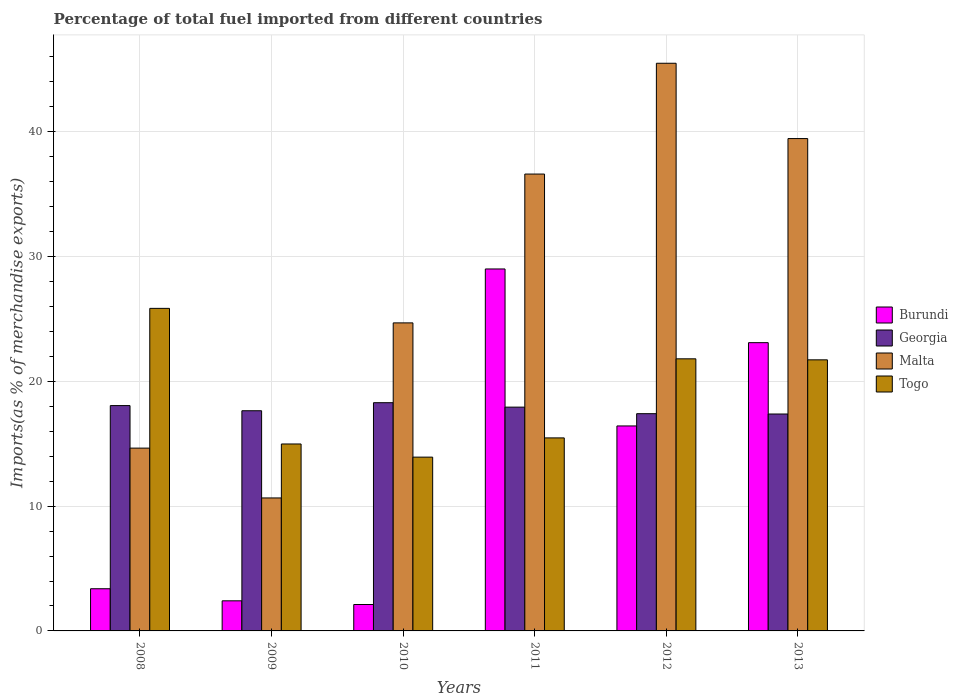How many groups of bars are there?
Provide a succinct answer. 6. Are the number of bars on each tick of the X-axis equal?
Give a very brief answer. Yes. How many bars are there on the 5th tick from the left?
Provide a succinct answer. 4. How many bars are there on the 6th tick from the right?
Your answer should be compact. 4. In how many cases, is the number of bars for a given year not equal to the number of legend labels?
Ensure brevity in your answer.  0. What is the percentage of imports to different countries in Togo in 2011?
Offer a very short reply. 15.47. Across all years, what is the maximum percentage of imports to different countries in Burundi?
Keep it short and to the point. 29. Across all years, what is the minimum percentage of imports to different countries in Georgia?
Offer a terse response. 17.38. In which year was the percentage of imports to different countries in Togo maximum?
Make the answer very short. 2008. What is the total percentage of imports to different countries in Burundi in the graph?
Offer a very short reply. 76.43. What is the difference between the percentage of imports to different countries in Burundi in 2011 and that in 2012?
Provide a succinct answer. 12.58. What is the difference between the percentage of imports to different countries in Togo in 2008 and the percentage of imports to different countries in Malta in 2011?
Your answer should be very brief. -10.76. What is the average percentage of imports to different countries in Togo per year?
Offer a terse response. 18.96. In the year 2008, what is the difference between the percentage of imports to different countries in Malta and percentage of imports to different countries in Burundi?
Your answer should be compact. 11.27. What is the ratio of the percentage of imports to different countries in Togo in 2009 to that in 2012?
Provide a succinct answer. 0.69. Is the percentage of imports to different countries in Malta in 2010 less than that in 2011?
Your response must be concise. Yes. What is the difference between the highest and the second highest percentage of imports to different countries in Georgia?
Offer a very short reply. 0.23. What is the difference between the highest and the lowest percentage of imports to different countries in Burundi?
Give a very brief answer. 26.89. In how many years, is the percentage of imports to different countries in Burundi greater than the average percentage of imports to different countries in Burundi taken over all years?
Your response must be concise. 3. Is the sum of the percentage of imports to different countries in Georgia in 2011 and 2012 greater than the maximum percentage of imports to different countries in Burundi across all years?
Provide a short and direct response. Yes. What does the 2nd bar from the left in 2013 represents?
Offer a terse response. Georgia. What does the 1st bar from the right in 2012 represents?
Ensure brevity in your answer.  Togo. Is it the case that in every year, the sum of the percentage of imports to different countries in Malta and percentage of imports to different countries in Togo is greater than the percentage of imports to different countries in Georgia?
Keep it short and to the point. Yes. How many years are there in the graph?
Offer a very short reply. 6. Does the graph contain grids?
Offer a terse response. Yes. Where does the legend appear in the graph?
Your answer should be compact. Center right. How are the legend labels stacked?
Ensure brevity in your answer.  Vertical. What is the title of the graph?
Provide a short and direct response. Percentage of total fuel imported from different countries. Does "Arab World" appear as one of the legend labels in the graph?
Give a very brief answer. No. What is the label or title of the Y-axis?
Ensure brevity in your answer.  Imports(as % of merchandise exports). What is the Imports(as % of merchandise exports) of Burundi in 2008?
Offer a terse response. 3.38. What is the Imports(as % of merchandise exports) in Georgia in 2008?
Keep it short and to the point. 18.06. What is the Imports(as % of merchandise exports) in Malta in 2008?
Your answer should be compact. 14.65. What is the Imports(as % of merchandise exports) in Togo in 2008?
Your answer should be very brief. 25.85. What is the Imports(as % of merchandise exports) of Burundi in 2009?
Provide a short and direct response. 2.41. What is the Imports(as % of merchandise exports) in Georgia in 2009?
Offer a very short reply. 17.64. What is the Imports(as % of merchandise exports) in Malta in 2009?
Provide a succinct answer. 10.66. What is the Imports(as % of merchandise exports) of Togo in 2009?
Give a very brief answer. 14.98. What is the Imports(as % of merchandise exports) in Burundi in 2010?
Your answer should be compact. 2.12. What is the Imports(as % of merchandise exports) in Georgia in 2010?
Give a very brief answer. 18.29. What is the Imports(as % of merchandise exports) of Malta in 2010?
Give a very brief answer. 24.68. What is the Imports(as % of merchandise exports) of Togo in 2010?
Your answer should be very brief. 13.93. What is the Imports(as % of merchandise exports) of Burundi in 2011?
Provide a succinct answer. 29. What is the Imports(as % of merchandise exports) in Georgia in 2011?
Offer a very short reply. 17.93. What is the Imports(as % of merchandise exports) of Malta in 2011?
Provide a succinct answer. 36.61. What is the Imports(as % of merchandise exports) in Togo in 2011?
Offer a very short reply. 15.47. What is the Imports(as % of merchandise exports) in Burundi in 2012?
Your response must be concise. 16.42. What is the Imports(as % of merchandise exports) in Georgia in 2012?
Provide a short and direct response. 17.41. What is the Imports(as % of merchandise exports) of Malta in 2012?
Your response must be concise. 45.49. What is the Imports(as % of merchandise exports) in Togo in 2012?
Keep it short and to the point. 21.8. What is the Imports(as % of merchandise exports) of Burundi in 2013?
Your response must be concise. 23.1. What is the Imports(as % of merchandise exports) in Georgia in 2013?
Keep it short and to the point. 17.38. What is the Imports(as % of merchandise exports) in Malta in 2013?
Keep it short and to the point. 39.45. What is the Imports(as % of merchandise exports) in Togo in 2013?
Your response must be concise. 21.72. Across all years, what is the maximum Imports(as % of merchandise exports) in Burundi?
Keep it short and to the point. 29. Across all years, what is the maximum Imports(as % of merchandise exports) of Georgia?
Provide a short and direct response. 18.29. Across all years, what is the maximum Imports(as % of merchandise exports) of Malta?
Ensure brevity in your answer.  45.49. Across all years, what is the maximum Imports(as % of merchandise exports) in Togo?
Offer a very short reply. 25.85. Across all years, what is the minimum Imports(as % of merchandise exports) of Burundi?
Keep it short and to the point. 2.12. Across all years, what is the minimum Imports(as % of merchandise exports) in Georgia?
Keep it short and to the point. 17.38. Across all years, what is the minimum Imports(as % of merchandise exports) of Malta?
Offer a very short reply. 10.66. Across all years, what is the minimum Imports(as % of merchandise exports) of Togo?
Offer a very short reply. 13.93. What is the total Imports(as % of merchandise exports) of Burundi in the graph?
Keep it short and to the point. 76.43. What is the total Imports(as % of merchandise exports) in Georgia in the graph?
Keep it short and to the point. 106.7. What is the total Imports(as % of merchandise exports) of Malta in the graph?
Offer a very short reply. 171.53. What is the total Imports(as % of merchandise exports) in Togo in the graph?
Keep it short and to the point. 113.74. What is the difference between the Imports(as % of merchandise exports) in Burundi in 2008 and that in 2009?
Your response must be concise. 0.97. What is the difference between the Imports(as % of merchandise exports) of Georgia in 2008 and that in 2009?
Offer a terse response. 0.41. What is the difference between the Imports(as % of merchandise exports) of Malta in 2008 and that in 2009?
Give a very brief answer. 3.99. What is the difference between the Imports(as % of merchandise exports) of Togo in 2008 and that in 2009?
Provide a succinct answer. 10.87. What is the difference between the Imports(as % of merchandise exports) of Burundi in 2008 and that in 2010?
Your answer should be very brief. 1.26. What is the difference between the Imports(as % of merchandise exports) of Georgia in 2008 and that in 2010?
Give a very brief answer. -0.23. What is the difference between the Imports(as % of merchandise exports) of Malta in 2008 and that in 2010?
Provide a succinct answer. -10.03. What is the difference between the Imports(as % of merchandise exports) in Togo in 2008 and that in 2010?
Make the answer very short. 11.92. What is the difference between the Imports(as % of merchandise exports) of Burundi in 2008 and that in 2011?
Your answer should be compact. -25.62. What is the difference between the Imports(as % of merchandise exports) in Georgia in 2008 and that in 2011?
Offer a terse response. 0.12. What is the difference between the Imports(as % of merchandise exports) of Malta in 2008 and that in 2011?
Ensure brevity in your answer.  -21.96. What is the difference between the Imports(as % of merchandise exports) of Togo in 2008 and that in 2011?
Your answer should be very brief. 10.38. What is the difference between the Imports(as % of merchandise exports) in Burundi in 2008 and that in 2012?
Make the answer very short. -13.04. What is the difference between the Imports(as % of merchandise exports) in Georgia in 2008 and that in 2012?
Your answer should be very brief. 0.65. What is the difference between the Imports(as % of merchandise exports) in Malta in 2008 and that in 2012?
Make the answer very short. -30.84. What is the difference between the Imports(as % of merchandise exports) of Togo in 2008 and that in 2012?
Give a very brief answer. 4.04. What is the difference between the Imports(as % of merchandise exports) in Burundi in 2008 and that in 2013?
Offer a terse response. -19.72. What is the difference between the Imports(as % of merchandise exports) in Georgia in 2008 and that in 2013?
Offer a terse response. 0.67. What is the difference between the Imports(as % of merchandise exports) in Malta in 2008 and that in 2013?
Offer a very short reply. -24.8. What is the difference between the Imports(as % of merchandise exports) in Togo in 2008 and that in 2013?
Your answer should be compact. 4.12. What is the difference between the Imports(as % of merchandise exports) of Burundi in 2009 and that in 2010?
Your response must be concise. 0.3. What is the difference between the Imports(as % of merchandise exports) in Georgia in 2009 and that in 2010?
Offer a very short reply. -0.65. What is the difference between the Imports(as % of merchandise exports) in Malta in 2009 and that in 2010?
Offer a terse response. -14.03. What is the difference between the Imports(as % of merchandise exports) in Togo in 2009 and that in 2010?
Give a very brief answer. 1.05. What is the difference between the Imports(as % of merchandise exports) of Burundi in 2009 and that in 2011?
Your response must be concise. -26.59. What is the difference between the Imports(as % of merchandise exports) of Georgia in 2009 and that in 2011?
Your answer should be very brief. -0.29. What is the difference between the Imports(as % of merchandise exports) of Malta in 2009 and that in 2011?
Offer a terse response. -25.95. What is the difference between the Imports(as % of merchandise exports) of Togo in 2009 and that in 2011?
Your response must be concise. -0.49. What is the difference between the Imports(as % of merchandise exports) of Burundi in 2009 and that in 2012?
Keep it short and to the point. -14.01. What is the difference between the Imports(as % of merchandise exports) of Georgia in 2009 and that in 2012?
Make the answer very short. 0.23. What is the difference between the Imports(as % of merchandise exports) of Malta in 2009 and that in 2012?
Ensure brevity in your answer.  -34.83. What is the difference between the Imports(as % of merchandise exports) of Togo in 2009 and that in 2012?
Your answer should be compact. -6.82. What is the difference between the Imports(as % of merchandise exports) of Burundi in 2009 and that in 2013?
Make the answer very short. -20.69. What is the difference between the Imports(as % of merchandise exports) in Georgia in 2009 and that in 2013?
Keep it short and to the point. 0.26. What is the difference between the Imports(as % of merchandise exports) of Malta in 2009 and that in 2013?
Keep it short and to the point. -28.8. What is the difference between the Imports(as % of merchandise exports) of Togo in 2009 and that in 2013?
Provide a succinct answer. -6.74. What is the difference between the Imports(as % of merchandise exports) of Burundi in 2010 and that in 2011?
Offer a terse response. -26.89. What is the difference between the Imports(as % of merchandise exports) in Georgia in 2010 and that in 2011?
Ensure brevity in your answer.  0.36. What is the difference between the Imports(as % of merchandise exports) of Malta in 2010 and that in 2011?
Provide a succinct answer. -11.92. What is the difference between the Imports(as % of merchandise exports) in Togo in 2010 and that in 2011?
Provide a succinct answer. -1.54. What is the difference between the Imports(as % of merchandise exports) of Burundi in 2010 and that in 2012?
Your answer should be very brief. -14.31. What is the difference between the Imports(as % of merchandise exports) in Georgia in 2010 and that in 2012?
Ensure brevity in your answer.  0.88. What is the difference between the Imports(as % of merchandise exports) in Malta in 2010 and that in 2012?
Offer a very short reply. -20.8. What is the difference between the Imports(as % of merchandise exports) in Togo in 2010 and that in 2012?
Offer a terse response. -7.88. What is the difference between the Imports(as % of merchandise exports) in Burundi in 2010 and that in 2013?
Provide a short and direct response. -20.98. What is the difference between the Imports(as % of merchandise exports) in Georgia in 2010 and that in 2013?
Your answer should be compact. 0.91. What is the difference between the Imports(as % of merchandise exports) of Malta in 2010 and that in 2013?
Offer a terse response. -14.77. What is the difference between the Imports(as % of merchandise exports) of Togo in 2010 and that in 2013?
Ensure brevity in your answer.  -7.8. What is the difference between the Imports(as % of merchandise exports) of Burundi in 2011 and that in 2012?
Your answer should be compact. 12.58. What is the difference between the Imports(as % of merchandise exports) of Georgia in 2011 and that in 2012?
Ensure brevity in your answer.  0.52. What is the difference between the Imports(as % of merchandise exports) in Malta in 2011 and that in 2012?
Offer a very short reply. -8.88. What is the difference between the Imports(as % of merchandise exports) of Togo in 2011 and that in 2012?
Ensure brevity in your answer.  -6.34. What is the difference between the Imports(as % of merchandise exports) of Burundi in 2011 and that in 2013?
Give a very brief answer. 5.91. What is the difference between the Imports(as % of merchandise exports) of Georgia in 2011 and that in 2013?
Provide a succinct answer. 0.55. What is the difference between the Imports(as % of merchandise exports) of Malta in 2011 and that in 2013?
Provide a succinct answer. -2.84. What is the difference between the Imports(as % of merchandise exports) of Togo in 2011 and that in 2013?
Your answer should be very brief. -6.25. What is the difference between the Imports(as % of merchandise exports) of Burundi in 2012 and that in 2013?
Your answer should be compact. -6.67. What is the difference between the Imports(as % of merchandise exports) of Georgia in 2012 and that in 2013?
Ensure brevity in your answer.  0.03. What is the difference between the Imports(as % of merchandise exports) of Malta in 2012 and that in 2013?
Your response must be concise. 6.03. What is the difference between the Imports(as % of merchandise exports) in Togo in 2012 and that in 2013?
Your answer should be very brief. 0.08. What is the difference between the Imports(as % of merchandise exports) of Burundi in 2008 and the Imports(as % of merchandise exports) of Georgia in 2009?
Keep it short and to the point. -14.26. What is the difference between the Imports(as % of merchandise exports) of Burundi in 2008 and the Imports(as % of merchandise exports) of Malta in 2009?
Your answer should be very brief. -7.28. What is the difference between the Imports(as % of merchandise exports) in Burundi in 2008 and the Imports(as % of merchandise exports) in Togo in 2009?
Provide a short and direct response. -11.6. What is the difference between the Imports(as % of merchandise exports) in Georgia in 2008 and the Imports(as % of merchandise exports) in Malta in 2009?
Your answer should be very brief. 7.4. What is the difference between the Imports(as % of merchandise exports) of Georgia in 2008 and the Imports(as % of merchandise exports) of Togo in 2009?
Offer a very short reply. 3.08. What is the difference between the Imports(as % of merchandise exports) of Malta in 2008 and the Imports(as % of merchandise exports) of Togo in 2009?
Ensure brevity in your answer.  -0.33. What is the difference between the Imports(as % of merchandise exports) of Burundi in 2008 and the Imports(as % of merchandise exports) of Georgia in 2010?
Offer a terse response. -14.91. What is the difference between the Imports(as % of merchandise exports) of Burundi in 2008 and the Imports(as % of merchandise exports) of Malta in 2010?
Provide a short and direct response. -21.3. What is the difference between the Imports(as % of merchandise exports) in Burundi in 2008 and the Imports(as % of merchandise exports) in Togo in 2010?
Your answer should be very brief. -10.55. What is the difference between the Imports(as % of merchandise exports) of Georgia in 2008 and the Imports(as % of merchandise exports) of Malta in 2010?
Your response must be concise. -6.63. What is the difference between the Imports(as % of merchandise exports) of Georgia in 2008 and the Imports(as % of merchandise exports) of Togo in 2010?
Give a very brief answer. 4.13. What is the difference between the Imports(as % of merchandise exports) in Malta in 2008 and the Imports(as % of merchandise exports) in Togo in 2010?
Your response must be concise. 0.72. What is the difference between the Imports(as % of merchandise exports) in Burundi in 2008 and the Imports(as % of merchandise exports) in Georgia in 2011?
Your answer should be compact. -14.55. What is the difference between the Imports(as % of merchandise exports) of Burundi in 2008 and the Imports(as % of merchandise exports) of Malta in 2011?
Offer a terse response. -33.23. What is the difference between the Imports(as % of merchandise exports) in Burundi in 2008 and the Imports(as % of merchandise exports) in Togo in 2011?
Your response must be concise. -12.09. What is the difference between the Imports(as % of merchandise exports) of Georgia in 2008 and the Imports(as % of merchandise exports) of Malta in 2011?
Your response must be concise. -18.55. What is the difference between the Imports(as % of merchandise exports) in Georgia in 2008 and the Imports(as % of merchandise exports) in Togo in 2011?
Keep it short and to the point. 2.59. What is the difference between the Imports(as % of merchandise exports) in Malta in 2008 and the Imports(as % of merchandise exports) in Togo in 2011?
Give a very brief answer. -0.82. What is the difference between the Imports(as % of merchandise exports) in Burundi in 2008 and the Imports(as % of merchandise exports) in Georgia in 2012?
Provide a short and direct response. -14.03. What is the difference between the Imports(as % of merchandise exports) in Burundi in 2008 and the Imports(as % of merchandise exports) in Malta in 2012?
Give a very brief answer. -42.11. What is the difference between the Imports(as % of merchandise exports) in Burundi in 2008 and the Imports(as % of merchandise exports) in Togo in 2012?
Provide a succinct answer. -18.42. What is the difference between the Imports(as % of merchandise exports) of Georgia in 2008 and the Imports(as % of merchandise exports) of Malta in 2012?
Give a very brief answer. -27.43. What is the difference between the Imports(as % of merchandise exports) in Georgia in 2008 and the Imports(as % of merchandise exports) in Togo in 2012?
Your answer should be compact. -3.75. What is the difference between the Imports(as % of merchandise exports) in Malta in 2008 and the Imports(as % of merchandise exports) in Togo in 2012?
Offer a very short reply. -7.16. What is the difference between the Imports(as % of merchandise exports) in Burundi in 2008 and the Imports(as % of merchandise exports) in Georgia in 2013?
Provide a short and direct response. -14. What is the difference between the Imports(as % of merchandise exports) in Burundi in 2008 and the Imports(as % of merchandise exports) in Malta in 2013?
Make the answer very short. -36.07. What is the difference between the Imports(as % of merchandise exports) of Burundi in 2008 and the Imports(as % of merchandise exports) of Togo in 2013?
Make the answer very short. -18.34. What is the difference between the Imports(as % of merchandise exports) of Georgia in 2008 and the Imports(as % of merchandise exports) of Malta in 2013?
Offer a very short reply. -21.4. What is the difference between the Imports(as % of merchandise exports) in Georgia in 2008 and the Imports(as % of merchandise exports) in Togo in 2013?
Offer a terse response. -3.67. What is the difference between the Imports(as % of merchandise exports) of Malta in 2008 and the Imports(as % of merchandise exports) of Togo in 2013?
Keep it short and to the point. -7.07. What is the difference between the Imports(as % of merchandise exports) in Burundi in 2009 and the Imports(as % of merchandise exports) in Georgia in 2010?
Offer a very short reply. -15.88. What is the difference between the Imports(as % of merchandise exports) in Burundi in 2009 and the Imports(as % of merchandise exports) in Malta in 2010?
Ensure brevity in your answer.  -22.27. What is the difference between the Imports(as % of merchandise exports) of Burundi in 2009 and the Imports(as % of merchandise exports) of Togo in 2010?
Provide a succinct answer. -11.51. What is the difference between the Imports(as % of merchandise exports) of Georgia in 2009 and the Imports(as % of merchandise exports) of Malta in 2010?
Offer a terse response. -7.04. What is the difference between the Imports(as % of merchandise exports) of Georgia in 2009 and the Imports(as % of merchandise exports) of Togo in 2010?
Offer a very short reply. 3.72. What is the difference between the Imports(as % of merchandise exports) of Malta in 2009 and the Imports(as % of merchandise exports) of Togo in 2010?
Ensure brevity in your answer.  -3.27. What is the difference between the Imports(as % of merchandise exports) of Burundi in 2009 and the Imports(as % of merchandise exports) of Georgia in 2011?
Give a very brief answer. -15.52. What is the difference between the Imports(as % of merchandise exports) in Burundi in 2009 and the Imports(as % of merchandise exports) in Malta in 2011?
Offer a terse response. -34.2. What is the difference between the Imports(as % of merchandise exports) in Burundi in 2009 and the Imports(as % of merchandise exports) in Togo in 2011?
Provide a short and direct response. -13.05. What is the difference between the Imports(as % of merchandise exports) in Georgia in 2009 and the Imports(as % of merchandise exports) in Malta in 2011?
Provide a short and direct response. -18.96. What is the difference between the Imports(as % of merchandise exports) of Georgia in 2009 and the Imports(as % of merchandise exports) of Togo in 2011?
Make the answer very short. 2.18. What is the difference between the Imports(as % of merchandise exports) in Malta in 2009 and the Imports(as % of merchandise exports) in Togo in 2011?
Offer a terse response. -4.81. What is the difference between the Imports(as % of merchandise exports) in Burundi in 2009 and the Imports(as % of merchandise exports) in Georgia in 2012?
Make the answer very short. -15. What is the difference between the Imports(as % of merchandise exports) in Burundi in 2009 and the Imports(as % of merchandise exports) in Malta in 2012?
Your answer should be very brief. -43.07. What is the difference between the Imports(as % of merchandise exports) in Burundi in 2009 and the Imports(as % of merchandise exports) in Togo in 2012?
Provide a succinct answer. -19.39. What is the difference between the Imports(as % of merchandise exports) of Georgia in 2009 and the Imports(as % of merchandise exports) of Malta in 2012?
Make the answer very short. -27.84. What is the difference between the Imports(as % of merchandise exports) of Georgia in 2009 and the Imports(as % of merchandise exports) of Togo in 2012?
Provide a succinct answer. -4.16. What is the difference between the Imports(as % of merchandise exports) of Malta in 2009 and the Imports(as % of merchandise exports) of Togo in 2012?
Give a very brief answer. -11.15. What is the difference between the Imports(as % of merchandise exports) in Burundi in 2009 and the Imports(as % of merchandise exports) in Georgia in 2013?
Your response must be concise. -14.97. What is the difference between the Imports(as % of merchandise exports) of Burundi in 2009 and the Imports(as % of merchandise exports) of Malta in 2013?
Make the answer very short. -37.04. What is the difference between the Imports(as % of merchandise exports) in Burundi in 2009 and the Imports(as % of merchandise exports) in Togo in 2013?
Provide a short and direct response. -19.31. What is the difference between the Imports(as % of merchandise exports) of Georgia in 2009 and the Imports(as % of merchandise exports) of Malta in 2013?
Your answer should be compact. -21.81. What is the difference between the Imports(as % of merchandise exports) of Georgia in 2009 and the Imports(as % of merchandise exports) of Togo in 2013?
Ensure brevity in your answer.  -4.08. What is the difference between the Imports(as % of merchandise exports) of Malta in 2009 and the Imports(as % of merchandise exports) of Togo in 2013?
Your answer should be compact. -11.07. What is the difference between the Imports(as % of merchandise exports) in Burundi in 2010 and the Imports(as % of merchandise exports) in Georgia in 2011?
Make the answer very short. -15.81. What is the difference between the Imports(as % of merchandise exports) in Burundi in 2010 and the Imports(as % of merchandise exports) in Malta in 2011?
Ensure brevity in your answer.  -34.49. What is the difference between the Imports(as % of merchandise exports) of Burundi in 2010 and the Imports(as % of merchandise exports) of Togo in 2011?
Give a very brief answer. -13.35. What is the difference between the Imports(as % of merchandise exports) in Georgia in 2010 and the Imports(as % of merchandise exports) in Malta in 2011?
Provide a short and direct response. -18.32. What is the difference between the Imports(as % of merchandise exports) of Georgia in 2010 and the Imports(as % of merchandise exports) of Togo in 2011?
Your answer should be compact. 2.82. What is the difference between the Imports(as % of merchandise exports) in Malta in 2010 and the Imports(as % of merchandise exports) in Togo in 2011?
Keep it short and to the point. 9.22. What is the difference between the Imports(as % of merchandise exports) in Burundi in 2010 and the Imports(as % of merchandise exports) in Georgia in 2012?
Make the answer very short. -15.29. What is the difference between the Imports(as % of merchandise exports) of Burundi in 2010 and the Imports(as % of merchandise exports) of Malta in 2012?
Ensure brevity in your answer.  -43.37. What is the difference between the Imports(as % of merchandise exports) in Burundi in 2010 and the Imports(as % of merchandise exports) in Togo in 2012?
Offer a terse response. -19.69. What is the difference between the Imports(as % of merchandise exports) in Georgia in 2010 and the Imports(as % of merchandise exports) in Malta in 2012?
Your answer should be very brief. -27.2. What is the difference between the Imports(as % of merchandise exports) in Georgia in 2010 and the Imports(as % of merchandise exports) in Togo in 2012?
Your answer should be compact. -3.51. What is the difference between the Imports(as % of merchandise exports) in Malta in 2010 and the Imports(as % of merchandise exports) in Togo in 2012?
Offer a terse response. 2.88. What is the difference between the Imports(as % of merchandise exports) in Burundi in 2010 and the Imports(as % of merchandise exports) in Georgia in 2013?
Offer a terse response. -15.26. What is the difference between the Imports(as % of merchandise exports) of Burundi in 2010 and the Imports(as % of merchandise exports) of Malta in 2013?
Ensure brevity in your answer.  -37.33. What is the difference between the Imports(as % of merchandise exports) of Burundi in 2010 and the Imports(as % of merchandise exports) of Togo in 2013?
Make the answer very short. -19.6. What is the difference between the Imports(as % of merchandise exports) in Georgia in 2010 and the Imports(as % of merchandise exports) in Malta in 2013?
Give a very brief answer. -21.16. What is the difference between the Imports(as % of merchandise exports) in Georgia in 2010 and the Imports(as % of merchandise exports) in Togo in 2013?
Make the answer very short. -3.43. What is the difference between the Imports(as % of merchandise exports) of Malta in 2010 and the Imports(as % of merchandise exports) of Togo in 2013?
Your response must be concise. 2.96. What is the difference between the Imports(as % of merchandise exports) of Burundi in 2011 and the Imports(as % of merchandise exports) of Georgia in 2012?
Your answer should be compact. 11.6. What is the difference between the Imports(as % of merchandise exports) of Burundi in 2011 and the Imports(as % of merchandise exports) of Malta in 2012?
Your answer should be very brief. -16.48. What is the difference between the Imports(as % of merchandise exports) in Burundi in 2011 and the Imports(as % of merchandise exports) in Togo in 2012?
Your answer should be very brief. 7.2. What is the difference between the Imports(as % of merchandise exports) of Georgia in 2011 and the Imports(as % of merchandise exports) of Malta in 2012?
Provide a succinct answer. -27.55. What is the difference between the Imports(as % of merchandise exports) in Georgia in 2011 and the Imports(as % of merchandise exports) in Togo in 2012?
Make the answer very short. -3.87. What is the difference between the Imports(as % of merchandise exports) of Malta in 2011 and the Imports(as % of merchandise exports) of Togo in 2012?
Your answer should be very brief. 14.8. What is the difference between the Imports(as % of merchandise exports) in Burundi in 2011 and the Imports(as % of merchandise exports) in Georgia in 2013?
Provide a short and direct response. 11.62. What is the difference between the Imports(as % of merchandise exports) in Burundi in 2011 and the Imports(as % of merchandise exports) in Malta in 2013?
Offer a terse response. -10.45. What is the difference between the Imports(as % of merchandise exports) of Burundi in 2011 and the Imports(as % of merchandise exports) of Togo in 2013?
Give a very brief answer. 7.28. What is the difference between the Imports(as % of merchandise exports) in Georgia in 2011 and the Imports(as % of merchandise exports) in Malta in 2013?
Your answer should be compact. -21.52. What is the difference between the Imports(as % of merchandise exports) of Georgia in 2011 and the Imports(as % of merchandise exports) of Togo in 2013?
Make the answer very short. -3.79. What is the difference between the Imports(as % of merchandise exports) of Malta in 2011 and the Imports(as % of merchandise exports) of Togo in 2013?
Your response must be concise. 14.89. What is the difference between the Imports(as % of merchandise exports) in Burundi in 2012 and the Imports(as % of merchandise exports) in Georgia in 2013?
Keep it short and to the point. -0.96. What is the difference between the Imports(as % of merchandise exports) in Burundi in 2012 and the Imports(as % of merchandise exports) in Malta in 2013?
Give a very brief answer. -23.03. What is the difference between the Imports(as % of merchandise exports) in Burundi in 2012 and the Imports(as % of merchandise exports) in Togo in 2013?
Offer a terse response. -5.3. What is the difference between the Imports(as % of merchandise exports) of Georgia in 2012 and the Imports(as % of merchandise exports) of Malta in 2013?
Your response must be concise. -22.04. What is the difference between the Imports(as % of merchandise exports) in Georgia in 2012 and the Imports(as % of merchandise exports) in Togo in 2013?
Offer a terse response. -4.31. What is the difference between the Imports(as % of merchandise exports) in Malta in 2012 and the Imports(as % of merchandise exports) in Togo in 2013?
Make the answer very short. 23.76. What is the average Imports(as % of merchandise exports) of Burundi per year?
Your response must be concise. 12.74. What is the average Imports(as % of merchandise exports) in Georgia per year?
Provide a succinct answer. 17.78. What is the average Imports(as % of merchandise exports) in Malta per year?
Offer a very short reply. 28.59. What is the average Imports(as % of merchandise exports) of Togo per year?
Keep it short and to the point. 18.96. In the year 2008, what is the difference between the Imports(as % of merchandise exports) in Burundi and Imports(as % of merchandise exports) in Georgia?
Your answer should be compact. -14.68. In the year 2008, what is the difference between the Imports(as % of merchandise exports) in Burundi and Imports(as % of merchandise exports) in Malta?
Ensure brevity in your answer.  -11.27. In the year 2008, what is the difference between the Imports(as % of merchandise exports) of Burundi and Imports(as % of merchandise exports) of Togo?
Ensure brevity in your answer.  -22.46. In the year 2008, what is the difference between the Imports(as % of merchandise exports) of Georgia and Imports(as % of merchandise exports) of Malta?
Give a very brief answer. 3.41. In the year 2008, what is the difference between the Imports(as % of merchandise exports) of Georgia and Imports(as % of merchandise exports) of Togo?
Your answer should be very brief. -7.79. In the year 2008, what is the difference between the Imports(as % of merchandise exports) of Malta and Imports(as % of merchandise exports) of Togo?
Provide a succinct answer. -11.2. In the year 2009, what is the difference between the Imports(as % of merchandise exports) in Burundi and Imports(as % of merchandise exports) in Georgia?
Make the answer very short. -15.23. In the year 2009, what is the difference between the Imports(as % of merchandise exports) of Burundi and Imports(as % of merchandise exports) of Malta?
Your answer should be compact. -8.24. In the year 2009, what is the difference between the Imports(as % of merchandise exports) of Burundi and Imports(as % of merchandise exports) of Togo?
Provide a succinct answer. -12.57. In the year 2009, what is the difference between the Imports(as % of merchandise exports) of Georgia and Imports(as % of merchandise exports) of Malta?
Ensure brevity in your answer.  6.99. In the year 2009, what is the difference between the Imports(as % of merchandise exports) of Georgia and Imports(as % of merchandise exports) of Togo?
Ensure brevity in your answer.  2.66. In the year 2009, what is the difference between the Imports(as % of merchandise exports) in Malta and Imports(as % of merchandise exports) in Togo?
Provide a short and direct response. -4.32. In the year 2010, what is the difference between the Imports(as % of merchandise exports) of Burundi and Imports(as % of merchandise exports) of Georgia?
Your answer should be compact. -16.17. In the year 2010, what is the difference between the Imports(as % of merchandise exports) in Burundi and Imports(as % of merchandise exports) in Malta?
Your answer should be compact. -22.57. In the year 2010, what is the difference between the Imports(as % of merchandise exports) of Burundi and Imports(as % of merchandise exports) of Togo?
Your response must be concise. -11.81. In the year 2010, what is the difference between the Imports(as % of merchandise exports) in Georgia and Imports(as % of merchandise exports) in Malta?
Ensure brevity in your answer.  -6.39. In the year 2010, what is the difference between the Imports(as % of merchandise exports) of Georgia and Imports(as % of merchandise exports) of Togo?
Offer a terse response. 4.36. In the year 2010, what is the difference between the Imports(as % of merchandise exports) in Malta and Imports(as % of merchandise exports) in Togo?
Offer a terse response. 10.76. In the year 2011, what is the difference between the Imports(as % of merchandise exports) in Burundi and Imports(as % of merchandise exports) in Georgia?
Keep it short and to the point. 11.07. In the year 2011, what is the difference between the Imports(as % of merchandise exports) of Burundi and Imports(as % of merchandise exports) of Malta?
Offer a very short reply. -7.6. In the year 2011, what is the difference between the Imports(as % of merchandise exports) in Burundi and Imports(as % of merchandise exports) in Togo?
Provide a succinct answer. 13.54. In the year 2011, what is the difference between the Imports(as % of merchandise exports) in Georgia and Imports(as % of merchandise exports) in Malta?
Make the answer very short. -18.68. In the year 2011, what is the difference between the Imports(as % of merchandise exports) in Georgia and Imports(as % of merchandise exports) in Togo?
Ensure brevity in your answer.  2.46. In the year 2011, what is the difference between the Imports(as % of merchandise exports) in Malta and Imports(as % of merchandise exports) in Togo?
Offer a very short reply. 21.14. In the year 2012, what is the difference between the Imports(as % of merchandise exports) in Burundi and Imports(as % of merchandise exports) in Georgia?
Ensure brevity in your answer.  -0.98. In the year 2012, what is the difference between the Imports(as % of merchandise exports) in Burundi and Imports(as % of merchandise exports) in Malta?
Give a very brief answer. -29.06. In the year 2012, what is the difference between the Imports(as % of merchandise exports) of Burundi and Imports(as % of merchandise exports) of Togo?
Your answer should be compact. -5.38. In the year 2012, what is the difference between the Imports(as % of merchandise exports) of Georgia and Imports(as % of merchandise exports) of Malta?
Offer a very short reply. -28.08. In the year 2012, what is the difference between the Imports(as % of merchandise exports) in Georgia and Imports(as % of merchandise exports) in Togo?
Give a very brief answer. -4.4. In the year 2012, what is the difference between the Imports(as % of merchandise exports) of Malta and Imports(as % of merchandise exports) of Togo?
Your response must be concise. 23.68. In the year 2013, what is the difference between the Imports(as % of merchandise exports) of Burundi and Imports(as % of merchandise exports) of Georgia?
Keep it short and to the point. 5.72. In the year 2013, what is the difference between the Imports(as % of merchandise exports) of Burundi and Imports(as % of merchandise exports) of Malta?
Your answer should be compact. -16.35. In the year 2013, what is the difference between the Imports(as % of merchandise exports) of Burundi and Imports(as % of merchandise exports) of Togo?
Keep it short and to the point. 1.38. In the year 2013, what is the difference between the Imports(as % of merchandise exports) of Georgia and Imports(as % of merchandise exports) of Malta?
Ensure brevity in your answer.  -22.07. In the year 2013, what is the difference between the Imports(as % of merchandise exports) of Georgia and Imports(as % of merchandise exports) of Togo?
Ensure brevity in your answer.  -4.34. In the year 2013, what is the difference between the Imports(as % of merchandise exports) of Malta and Imports(as % of merchandise exports) of Togo?
Ensure brevity in your answer.  17.73. What is the ratio of the Imports(as % of merchandise exports) in Burundi in 2008 to that in 2009?
Keep it short and to the point. 1.4. What is the ratio of the Imports(as % of merchandise exports) in Georgia in 2008 to that in 2009?
Give a very brief answer. 1.02. What is the ratio of the Imports(as % of merchandise exports) in Malta in 2008 to that in 2009?
Ensure brevity in your answer.  1.37. What is the ratio of the Imports(as % of merchandise exports) in Togo in 2008 to that in 2009?
Your answer should be very brief. 1.73. What is the ratio of the Imports(as % of merchandise exports) in Burundi in 2008 to that in 2010?
Your answer should be very brief. 1.6. What is the ratio of the Imports(as % of merchandise exports) of Georgia in 2008 to that in 2010?
Offer a terse response. 0.99. What is the ratio of the Imports(as % of merchandise exports) in Malta in 2008 to that in 2010?
Ensure brevity in your answer.  0.59. What is the ratio of the Imports(as % of merchandise exports) in Togo in 2008 to that in 2010?
Make the answer very short. 1.86. What is the ratio of the Imports(as % of merchandise exports) in Burundi in 2008 to that in 2011?
Your answer should be very brief. 0.12. What is the ratio of the Imports(as % of merchandise exports) of Georgia in 2008 to that in 2011?
Your response must be concise. 1.01. What is the ratio of the Imports(as % of merchandise exports) in Malta in 2008 to that in 2011?
Provide a short and direct response. 0.4. What is the ratio of the Imports(as % of merchandise exports) in Togo in 2008 to that in 2011?
Your answer should be very brief. 1.67. What is the ratio of the Imports(as % of merchandise exports) in Burundi in 2008 to that in 2012?
Your response must be concise. 0.21. What is the ratio of the Imports(as % of merchandise exports) of Georgia in 2008 to that in 2012?
Ensure brevity in your answer.  1.04. What is the ratio of the Imports(as % of merchandise exports) in Malta in 2008 to that in 2012?
Make the answer very short. 0.32. What is the ratio of the Imports(as % of merchandise exports) in Togo in 2008 to that in 2012?
Keep it short and to the point. 1.19. What is the ratio of the Imports(as % of merchandise exports) of Burundi in 2008 to that in 2013?
Your answer should be compact. 0.15. What is the ratio of the Imports(as % of merchandise exports) in Georgia in 2008 to that in 2013?
Your answer should be very brief. 1.04. What is the ratio of the Imports(as % of merchandise exports) of Malta in 2008 to that in 2013?
Offer a very short reply. 0.37. What is the ratio of the Imports(as % of merchandise exports) in Togo in 2008 to that in 2013?
Your answer should be very brief. 1.19. What is the ratio of the Imports(as % of merchandise exports) in Burundi in 2009 to that in 2010?
Give a very brief answer. 1.14. What is the ratio of the Imports(as % of merchandise exports) in Georgia in 2009 to that in 2010?
Keep it short and to the point. 0.96. What is the ratio of the Imports(as % of merchandise exports) in Malta in 2009 to that in 2010?
Your answer should be compact. 0.43. What is the ratio of the Imports(as % of merchandise exports) of Togo in 2009 to that in 2010?
Keep it short and to the point. 1.08. What is the ratio of the Imports(as % of merchandise exports) of Burundi in 2009 to that in 2011?
Offer a very short reply. 0.08. What is the ratio of the Imports(as % of merchandise exports) in Georgia in 2009 to that in 2011?
Provide a succinct answer. 0.98. What is the ratio of the Imports(as % of merchandise exports) of Malta in 2009 to that in 2011?
Provide a short and direct response. 0.29. What is the ratio of the Imports(as % of merchandise exports) of Togo in 2009 to that in 2011?
Your answer should be compact. 0.97. What is the ratio of the Imports(as % of merchandise exports) in Burundi in 2009 to that in 2012?
Offer a very short reply. 0.15. What is the ratio of the Imports(as % of merchandise exports) of Georgia in 2009 to that in 2012?
Your response must be concise. 1.01. What is the ratio of the Imports(as % of merchandise exports) of Malta in 2009 to that in 2012?
Provide a short and direct response. 0.23. What is the ratio of the Imports(as % of merchandise exports) of Togo in 2009 to that in 2012?
Your response must be concise. 0.69. What is the ratio of the Imports(as % of merchandise exports) in Burundi in 2009 to that in 2013?
Provide a succinct answer. 0.1. What is the ratio of the Imports(as % of merchandise exports) in Malta in 2009 to that in 2013?
Offer a terse response. 0.27. What is the ratio of the Imports(as % of merchandise exports) in Togo in 2009 to that in 2013?
Offer a terse response. 0.69. What is the ratio of the Imports(as % of merchandise exports) of Burundi in 2010 to that in 2011?
Offer a very short reply. 0.07. What is the ratio of the Imports(as % of merchandise exports) in Georgia in 2010 to that in 2011?
Make the answer very short. 1.02. What is the ratio of the Imports(as % of merchandise exports) in Malta in 2010 to that in 2011?
Your answer should be compact. 0.67. What is the ratio of the Imports(as % of merchandise exports) in Togo in 2010 to that in 2011?
Provide a succinct answer. 0.9. What is the ratio of the Imports(as % of merchandise exports) of Burundi in 2010 to that in 2012?
Provide a succinct answer. 0.13. What is the ratio of the Imports(as % of merchandise exports) of Georgia in 2010 to that in 2012?
Give a very brief answer. 1.05. What is the ratio of the Imports(as % of merchandise exports) of Malta in 2010 to that in 2012?
Provide a succinct answer. 0.54. What is the ratio of the Imports(as % of merchandise exports) of Togo in 2010 to that in 2012?
Provide a short and direct response. 0.64. What is the ratio of the Imports(as % of merchandise exports) of Burundi in 2010 to that in 2013?
Offer a terse response. 0.09. What is the ratio of the Imports(as % of merchandise exports) in Georgia in 2010 to that in 2013?
Your answer should be compact. 1.05. What is the ratio of the Imports(as % of merchandise exports) of Malta in 2010 to that in 2013?
Your response must be concise. 0.63. What is the ratio of the Imports(as % of merchandise exports) in Togo in 2010 to that in 2013?
Keep it short and to the point. 0.64. What is the ratio of the Imports(as % of merchandise exports) of Burundi in 2011 to that in 2012?
Ensure brevity in your answer.  1.77. What is the ratio of the Imports(as % of merchandise exports) of Georgia in 2011 to that in 2012?
Keep it short and to the point. 1.03. What is the ratio of the Imports(as % of merchandise exports) of Malta in 2011 to that in 2012?
Make the answer very short. 0.8. What is the ratio of the Imports(as % of merchandise exports) in Togo in 2011 to that in 2012?
Your answer should be very brief. 0.71. What is the ratio of the Imports(as % of merchandise exports) in Burundi in 2011 to that in 2013?
Your response must be concise. 1.26. What is the ratio of the Imports(as % of merchandise exports) in Georgia in 2011 to that in 2013?
Offer a terse response. 1.03. What is the ratio of the Imports(as % of merchandise exports) of Malta in 2011 to that in 2013?
Your answer should be very brief. 0.93. What is the ratio of the Imports(as % of merchandise exports) of Togo in 2011 to that in 2013?
Provide a short and direct response. 0.71. What is the ratio of the Imports(as % of merchandise exports) in Burundi in 2012 to that in 2013?
Make the answer very short. 0.71. What is the ratio of the Imports(as % of merchandise exports) of Georgia in 2012 to that in 2013?
Provide a succinct answer. 1. What is the ratio of the Imports(as % of merchandise exports) of Malta in 2012 to that in 2013?
Make the answer very short. 1.15. What is the difference between the highest and the second highest Imports(as % of merchandise exports) in Burundi?
Provide a succinct answer. 5.91. What is the difference between the highest and the second highest Imports(as % of merchandise exports) in Georgia?
Your response must be concise. 0.23. What is the difference between the highest and the second highest Imports(as % of merchandise exports) of Malta?
Give a very brief answer. 6.03. What is the difference between the highest and the second highest Imports(as % of merchandise exports) of Togo?
Provide a succinct answer. 4.04. What is the difference between the highest and the lowest Imports(as % of merchandise exports) of Burundi?
Your response must be concise. 26.89. What is the difference between the highest and the lowest Imports(as % of merchandise exports) of Georgia?
Provide a succinct answer. 0.91. What is the difference between the highest and the lowest Imports(as % of merchandise exports) in Malta?
Offer a terse response. 34.83. What is the difference between the highest and the lowest Imports(as % of merchandise exports) in Togo?
Ensure brevity in your answer.  11.92. 